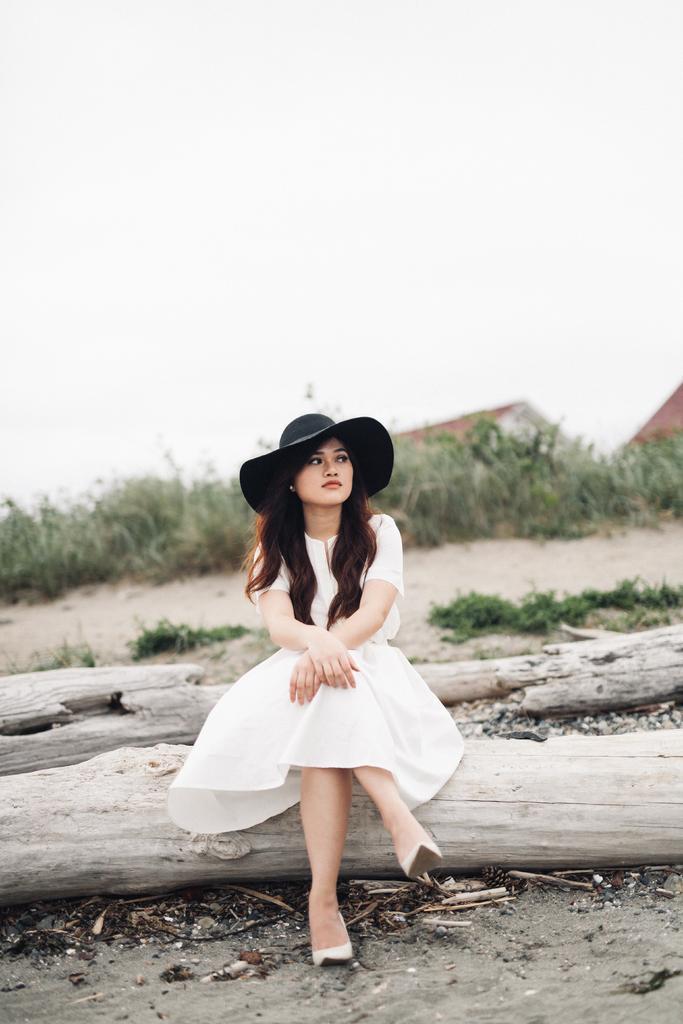Can you describe this image briefly? In this picture I can see a woman seated on the tree bark and I can see couple of tree barks on the side and I can see plants and couple of houses and a cloudy sky. 